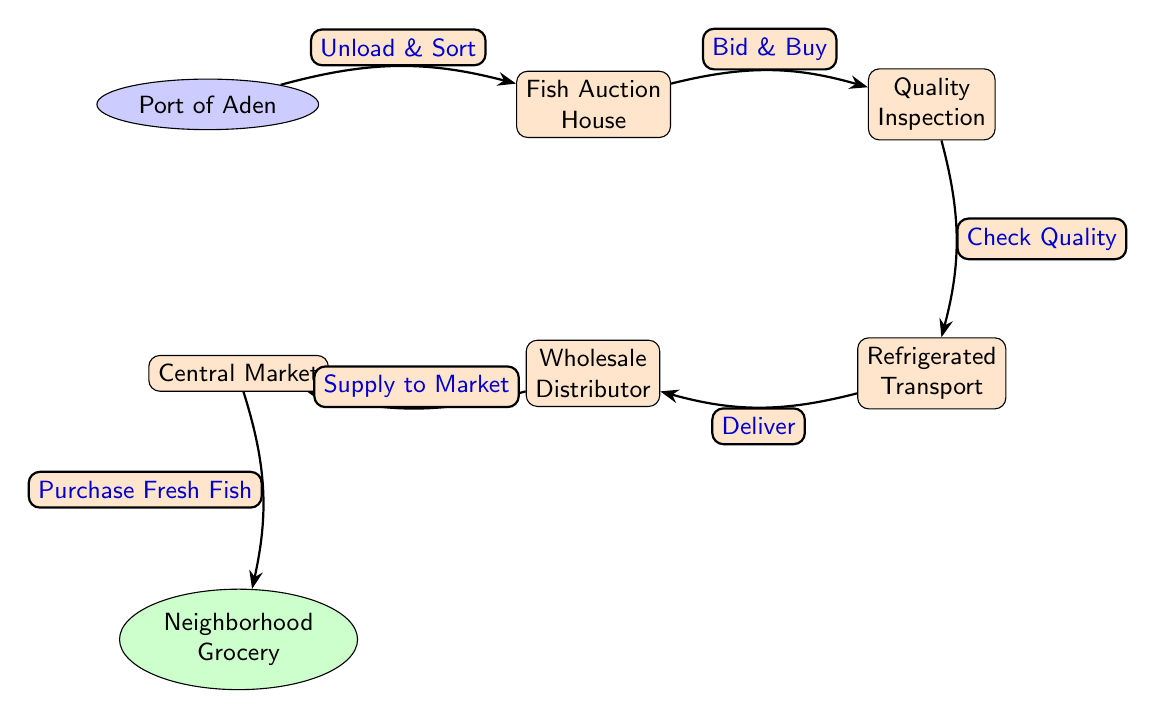What is the first node in the food chain? The first node in the food chain indicates the initial point of entry for the fish, which is the Port of Aden.
Answer: Port of Aden How many nodes are there in the diagram? The diagram consists of six distinct nodes representing various stages in the food chain from the Port to the Grocery.
Answer: 6 What action occurs between the Port of Aden and the Fish Auction House? The action denoted between these two nodes is 'Unload & Sort', indicating the process of handling the fish upon arrival.
Answer: Unload & Sort Which node follows the Quality Inspection? The node that comes directly after the Quality Inspection is the Refrigerated Transport, reflecting the next step in the process of delivering fish.
Answer: Refrigerated Transport What is the final destination of the fish in this food chain? The last node in the flow of the diagram is the Neighborhood Grocery, where the fish eventually reaches for sale to customers.
Answer: Neighborhood Grocery What action is performed at the Central Market? At the Central Market, the action represented is 'Purchase Fresh Fish', signifying the transaction that occurs at this point.
Answer: Purchase Fresh Fish What does the Wholesale Distributor do in this food chain? The Wholesale Distributor is responsible for 'Supply to Market', meaning they identify the distribution of fish to the Central Market.
Answer: Supply to Market Which nodes are directly connected? The directly connected nodes in the diagram include Port of Aden to Fish Auction House, Fish Auction House to Quality Inspection, Quality Inspection to Refrigerated Transport, Refrigerated Transport to Wholesale Distributor, Wholesale Distributor to Central Market, and Central Market to Neighborhood Grocery.
Answer: 6 connections What is the quality control step in this diagram? The quality control step is represented by 'Check Quality', which occurs after the bidding process at the Fish Auction House.
Answer: Check Quality 